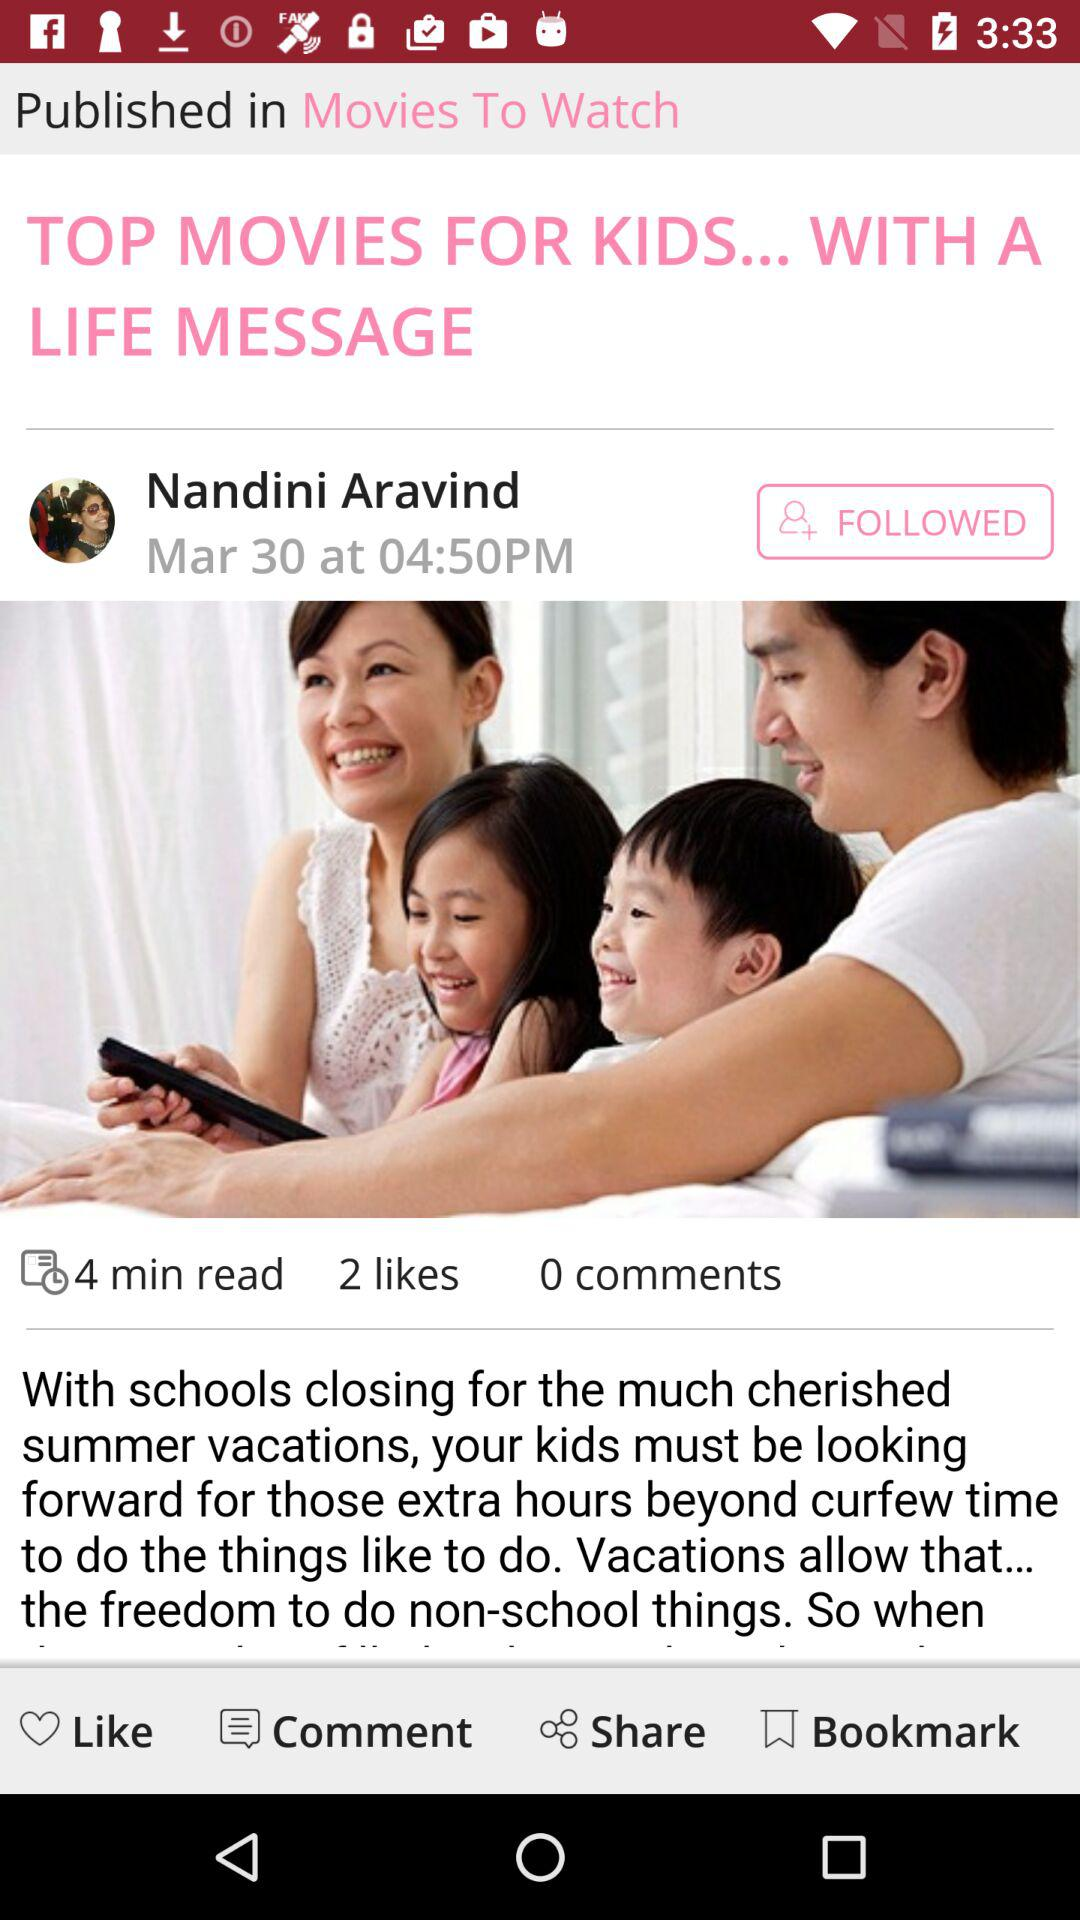How many more likes does the post have than comments?
Answer the question using a single word or phrase. 2 